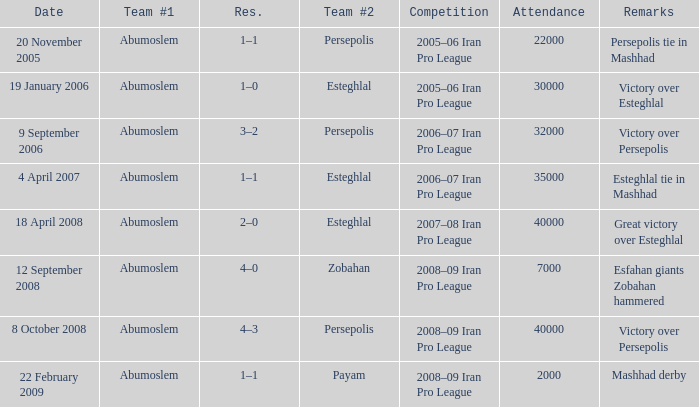What date was the attendance 22000? 20 November 2005. 